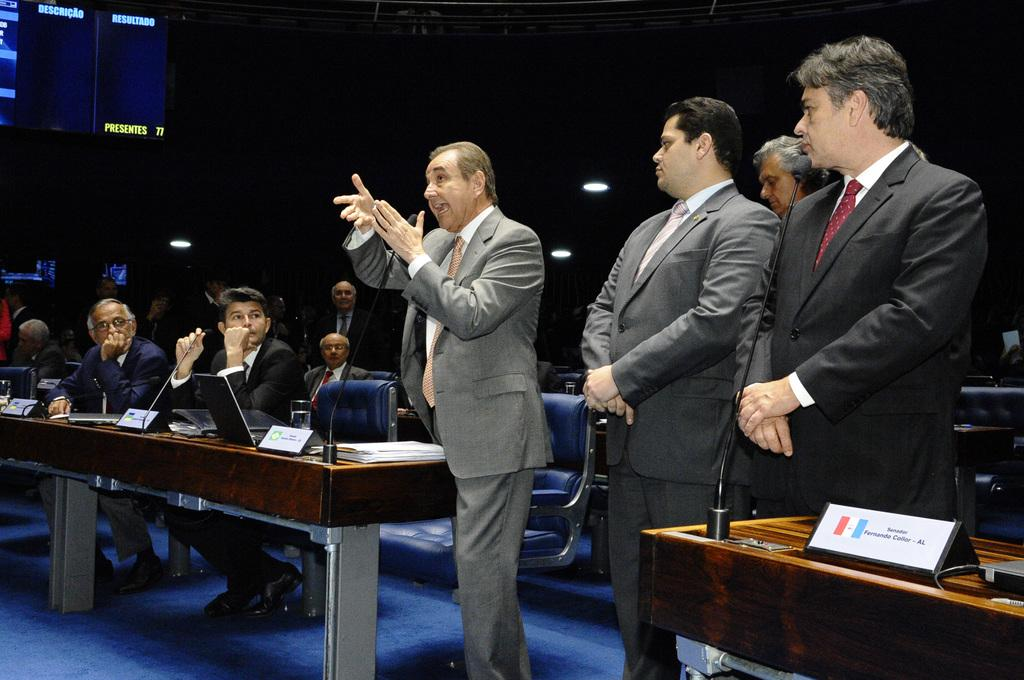How many people are in the image? There are people in the image, but the exact number is not specified. What are some of the people doing in the image? Some people are standing, and some are sitting on chairs. What objects can be seen in the image that are related to communication or technology? There are microphones (mics) and laptops in the image. What type of material might be used for writing or note-taking in the image? There are papers in the image. What is the texture of the grandmother's partner's sweater in the image? There is no mention of a grandmother, partner, or sweater in the image, so we cannot determine the texture of any sweater. 